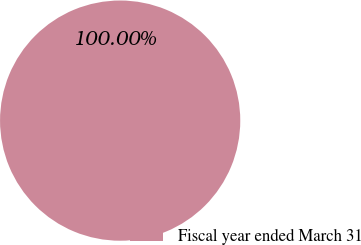Convert chart. <chart><loc_0><loc_0><loc_500><loc_500><pie_chart><fcel>Fiscal year ended March 31<nl><fcel>100.0%<nl></chart> 